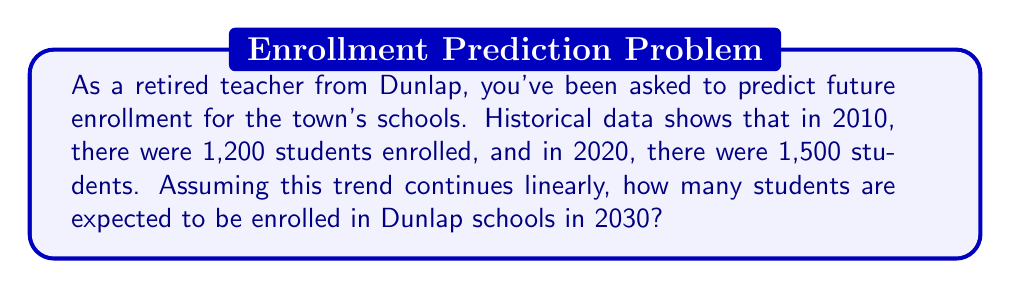Can you answer this question? Let's approach this step-by-step using a linear equation:

1) First, we need to find the slope (m) of our linear equation. The slope represents the rate of change in enrollment per year.

   $m = \frac{\text{change in enrollment}}{\text{change in years}} = \frac{1500 - 1200}{2020 - 2010} = \frac{300}{10} = 30$

   This means the enrollment is increasing by 30 students per year.

2) Now we can use the point-slope form of a linear equation:
   $y - y_1 = m(x - x_1)$

   Let's use the 2020 data point (2020, 1500) as our $(x_1, y_1)$:

   $y - 1500 = 30(x - 2020)$

3) Simplify this equation:
   $y = 30x - 60600 + 1500$
   $y = 30x - 59100$

4) To find the enrollment in 2030, we plug in x = 2030:

   $y = 30(2030) - 59100$
   $y = 60900 - 59100$
   $y = 1800$

Therefore, if this linear trend continues, we expect 1,800 students to be enrolled in Dunlap schools in 2030.
Answer: 1,800 students 